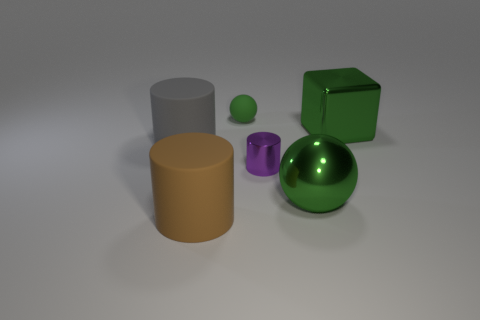Subtract all large brown rubber cylinders. How many cylinders are left? 2 Subtract 1 blocks. How many blocks are left? 0 Subtract all brown cylinders. How many cylinders are left? 2 Subtract all cyan spheres. How many gray cylinders are left? 1 Add 2 small purple cubes. How many objects exist? 8 Subtract all balls. How many objects are left? 4 Subtract all blue spheres. Subtract all brown cubes. How many spheres are left? 2 Subtract all small yellow metal things. Subtract all purple things. How many objects are left? 5 Add 6 tiny green spheres. How many tiny green spheres are left? 7 Add 1 gray matte cylinders. How many gray matte cylinders exist? 2 